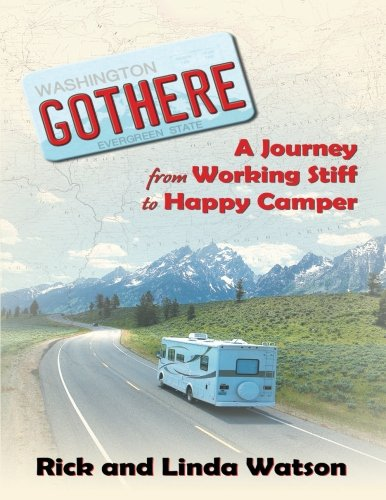What is the title of this book? The title of the book is 'Gothere: A Journey From Working Stiff to Happy Camper', written by Rick and Linda Watson. The cover suggests a narrative about travel and personal transformation. 